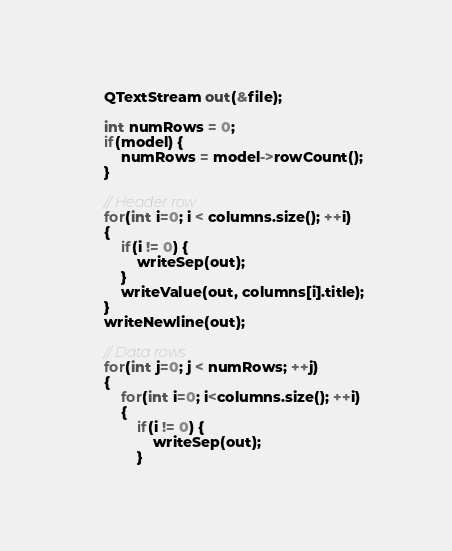<code> <loc_0><loc_0><loc_500><loc_500><_C++_>    QTextStream out(&file);

    int numRows = 0;
    if(model) {
        numRows = model->rowCount();
    }

    // Header row
    for(int i=0; i < columns.size(); ++i)
    {
        if(i != 0) {
            writeSep(out);
        }
        writeValue(out, columns[i].title);
    }
    writeNewline(out);

    // Data rows
    for(int j=0; j < numRows; ++j)
    {
        for(int i=0; i<columns.size(); ++i)
        {
            if(i != 0) {
                writeSep(out);
            }</code> 